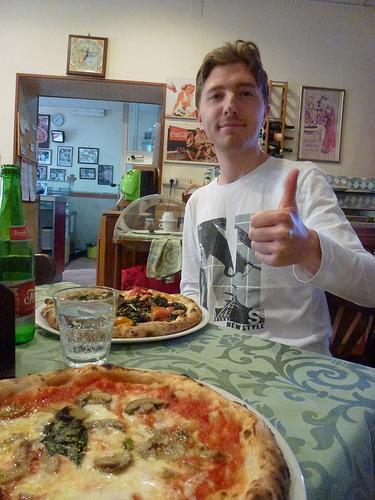How many pizzas are on the table?
Give a very brief answer. 2. 